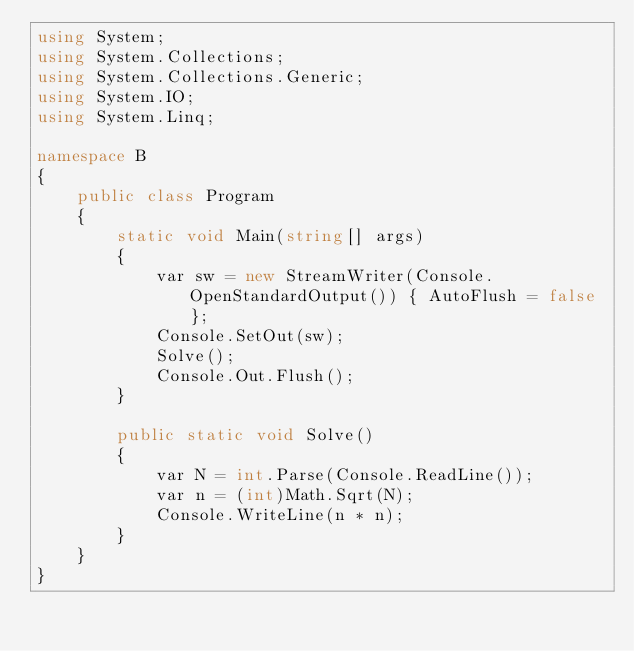<code> <loc_0><loc_0><loc_500><loc_500><_C#_>using System;
using System.Collections;
using System.Collections.Generic;
using System.IO;
using System.Linq;

namespace B
{
    public class Program
    {
        static void Main(string[] args)
        {
            var sw = new StreamWriter(Console.OpenStandardOutput()) { AutoFlush = false };
            Console.SetOut(sw);
            Solve();
            Console.Out.Flush();
        }

        public static void Solve()
        {
            var N = int.Parse(Console.ReadLine());
            var n = (int)Math.Sqrt(N);
            Console.WriteLine(n * n);
        }
    }
}
</code> 